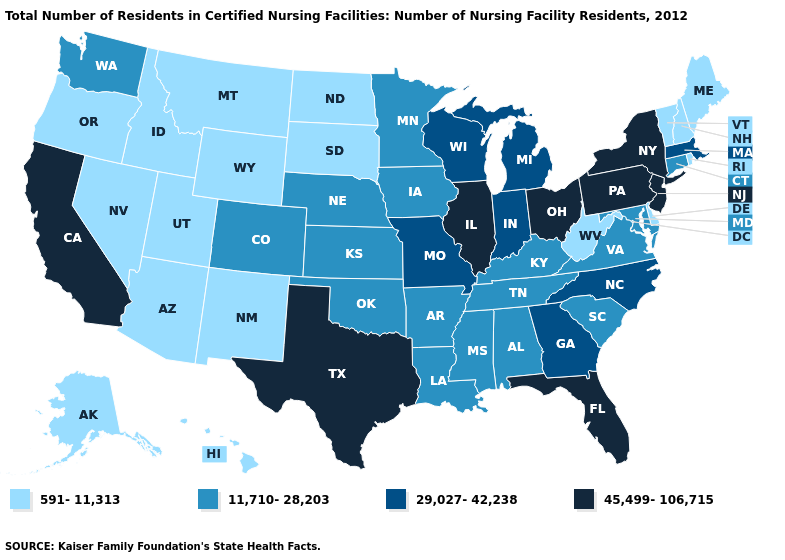Which states hav the highest value in the MidWest?
Quick response, please. Illinois, Ohio. Does the first symbol in the legend represent the smallest category?
Write a very short answer. Yes. Which states have the lowest value in the South?
Short answer required. Delaware, West Virginia. What is the value of Tennessee?
Give a very brief answer. 11,710-28,203. Among the states that border Virginia , does Tennessee have the highest value?
Write a very short answer. No. Does Colorado have a higher value than West Virginia?
Keep it brief. Yes. Name the states that have a value in the range 29,027-42,238?
Short answer required. Georgia, Indiana, Massachusetts, Michigan, Missouri, North Carolina, Wisconsin. Name the states that have a value in the range 11,710-28,203?
Quick response, please. Alabama, Arkansas, Colorado, Connecticut, Iowa, Kansas, Kentucky, Louisiana, Maryland, Minnesota, Mississippi, Nebraska, Oklahoma, South Carolina, Tennessee, Virginia, Washington. Name the states that have a value in the range 591-11,313?
Short answer required. Alaska, Arizona, Delaware, Hawaii, Idaho, Maine, Montana, Nevada, New Hampshire, New Mexico, North Dakota, Oregon, Rhode Island, South Dakota, Utah, Vermont, West Virginia, Wyoming. What is the value of Tennessee?
Answer briefly. 11,710-28,203. What is the value of Washington?
Give a very brief answer. 11,710-28,203. Name the states that have a value in the range 591-11,313?
Short answer required. Alaska, Arizona, Delaware, Hawaii, Idaho, Maine, Montana, Nevada, New Hampshire, New Mexico, North Dakota, Oregon, Rhode Island, South Dakota, Utah, Vermont, West Virginia, Wyoming. What is the value of Tennessee?
Keep it brief. 11,710-28,203. Is the legend a continuous bar?
Answer briefly. No. Does Maryland have the same value as Pennsylvania?
Write a very short answer. No. 